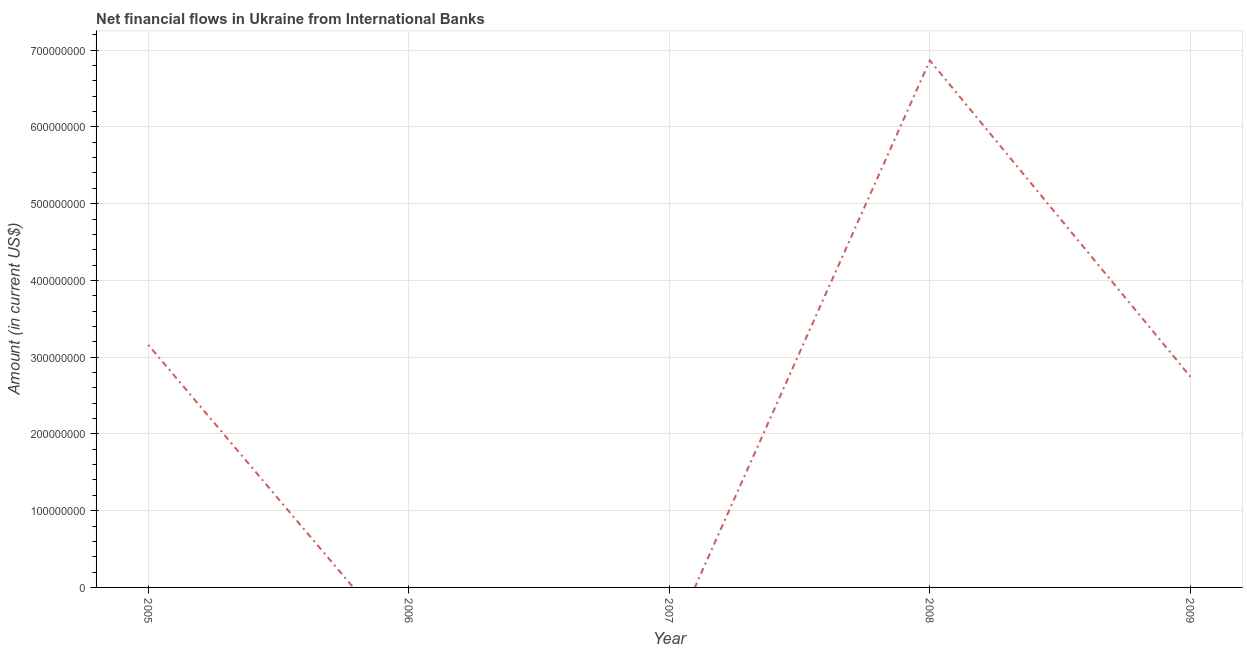What is the net financial flows from ibrd in 2005?
Your answer should be compact. 3.16e+08. Across all years, what is the maximum net financial flows from ibrd?
Your answer should be compact. 6.87e+08. What is the sum of the net financial flows from ibrd?
Give a very brief answer. 1.28e+09. What is the difference between the net financial flows from ibrd in 2008 and 2009?
Keep it short and to the point. 4.12e+08. What is the average net financial flows from ibrd per year?
Your response must be concise. 2.55e+08. What is the median net financial flows from ibrd?
Your answer should be compact. 2.75e+08. What is the ratio of the net financial flows from ibrd in 2008 to that in 2009?
Provide a succinct answer. 2.5. Is the difference between the net financial flows from ibrd in 2008 and 2009 greater than the difference between any two years?
Ensure brevity in your answer.  No. What is the difference between the highest and the second highest net financial flows from ibrd?
Your response must be concise. 3.71e+08. What is the difference between the highest and the lowest net financial flows from ibrd?
Provide a succinct answer. 6.87e+08. In how many years, is the net financial flows from ibrd greater than the average net financial flows from ibrd taken over all years?
Provide a succinct answer. 3. Does the net financial flows from ibrd monotonically increase over the years?
Ensure brevity in your answer.  No. How many lines are there?
Your response must be concise. 1. How many years are there in the graph?
Ensure brevity in your answer.  5. What is the difference between two consecutive major ticks on the Y-axis?
Your response must be concise. 1.00e+08. Does the graph contain any zero values?
Make the answer very short. Yes. Does the graph contain grids?
Your response must be concise. Yes. What is the title of the graph?
Make the answer very short. Net financial flows in Ukraine from International Banks. What is the label or title of the X-axis?
Offer a terse response. Year. What is the label or title of the Y-axis?
Provide a short and direct response. Amount (in current US$). What is the Amount (in current US$) of 2005?
Give a very brief answer. 3.16e+08. What is the Amount (in current US$) in 2008?
Keep it short and to the point. 6.87e+08. What is the Amount (in current US$) of 2009?
Keep it short and to the point. 2.75e+08. What is the difference between the Amount (in current US$) in 2005 and 2008?
Offer a very short reply. -3.71e+08. What is the difference between the Amount (in current US$) in 2005 and 2009?
Give a very brief answer. 4.15e+07. What is the difference between the Amount (in current US$) in 2008 and 2009?
Ensure brevity in your answer.  4.12e+08. What is the ratio of the Amount (in current US$) in 2005 to that in 2008?
Your response must be concise. 0.46. What is the ratio of the Amount (in current US$) in 2005 to that in 2009?
Your answer should be very brief. 1.15. What is the ratio of the Amount (in current US$) in 2008 to that in 2009?
Your response must be concise. 2.5. 